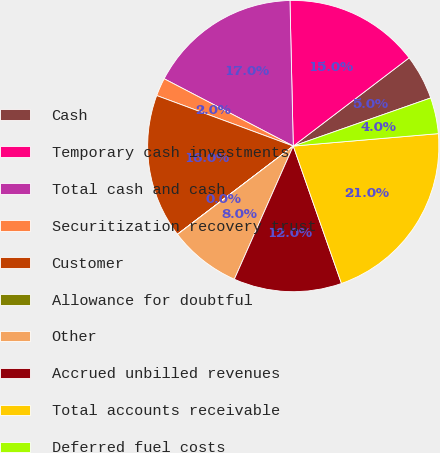<chart> <loc_0><loc_0><loc_500><loc_500><pie_chart><fcel>Cash<fcel>Temporary cash investments<fcel>Total cash and cash<fcel>Securitization recovery trust<fcel>Customer<fcel>Allowance for doubtful<fcel>Other<fcel>Accrued unbilled revenues<fcel>Total accounts receivable<fcel>Deferred fuel costs<nl><fcel>5.0%<fcel>15.0%<fcel>16.99%<fcel>2.01%<fcel>16.0%<fcel>0.01%<fcel>8.0%<fcel>12.0%<fcel>20.99%<fcel>4.0%<nl></chart> 